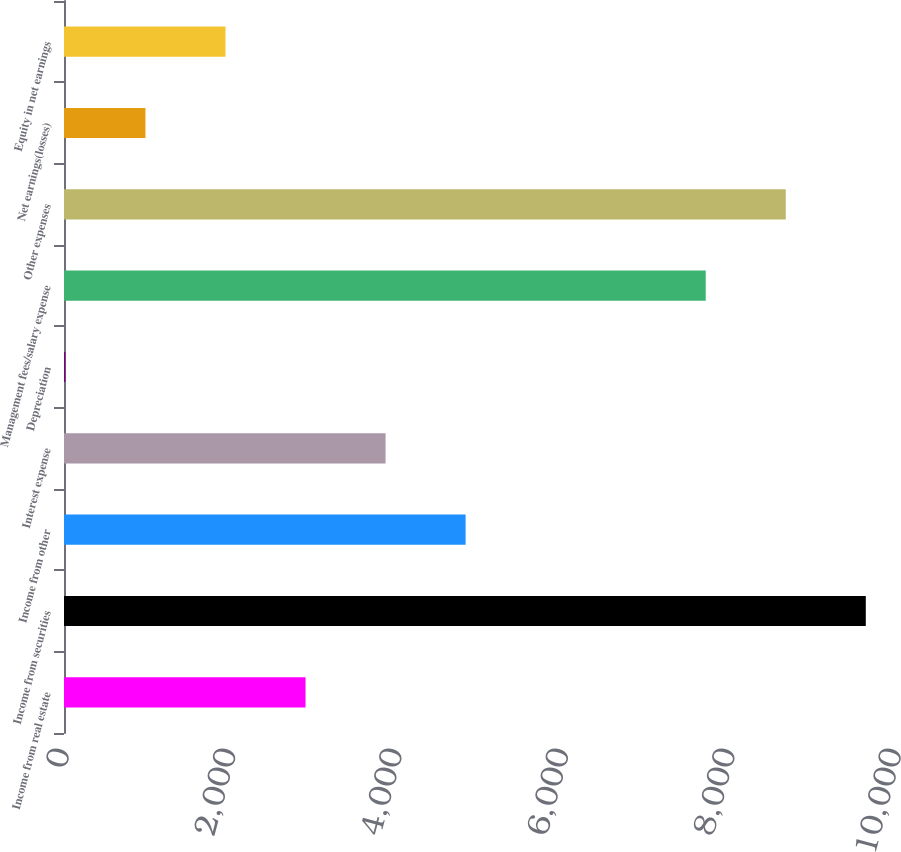Convert chart. <chart><loc_0><loc_0><loc_500><loc_500><bar_chart><fcel>Income from real estate<fcel>Income from securities<fcel>Income from other<fcel>Interest expense<fcel>Depreciation<fcel>Management fees/salary expense<fcel>Other expenses<fcel>Net earnings(losses)<fcel>Equity in net earnings<nl><fcel>2903<fcel>9637<fcel>4827<fcel>3865<fcel>17<fcel>7713<fcel>8675<fcel>979<fcel>1941<nl></chart> 